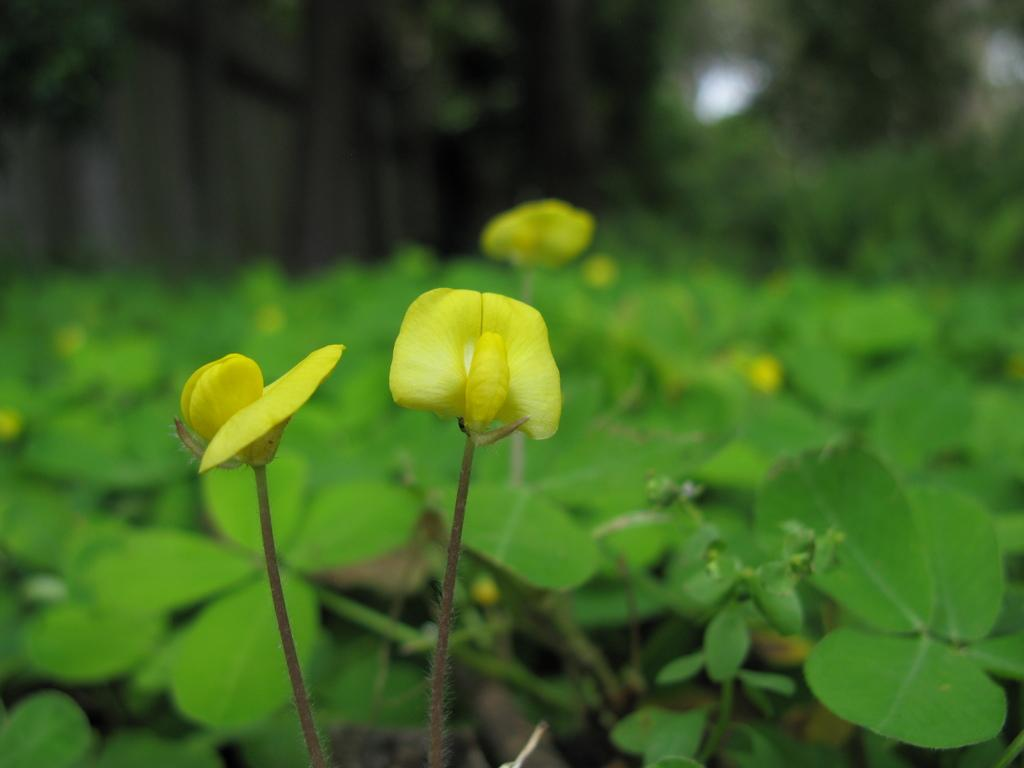What color are the flowers in the image? The flowers in the image are yellow. What can be seen in the background of the image? There are plants on the ground in the background of the image. How would you describe the background of the image? The background of the image is blurred. What type of toy can be seen in the image? There is no toy present in the image. What show is being performed in the image? There is no show being performed in the image. 